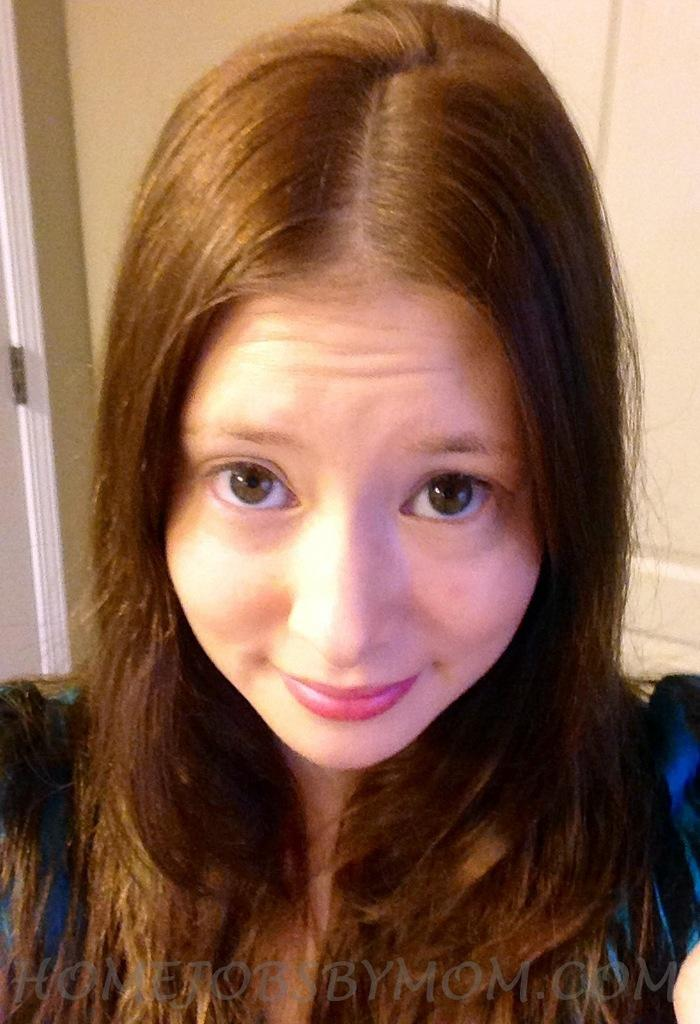Who is the main subject in the image? There is a girl in the image. What is the girl wearing? The girl is wearing a blue dress. What can be seen behind the girl? There is a wall behind the girl. Can you identify any architectural features in the image? Yes, there is a door in the image. What type of toad can be seen sitting on the girl's shoulder in the image? There is no toad present in the image; the girl is the main subject. What color are the crayons that the girl is using to draw in the image? There is no indication that the girl is using crayons or drawing in the image. 